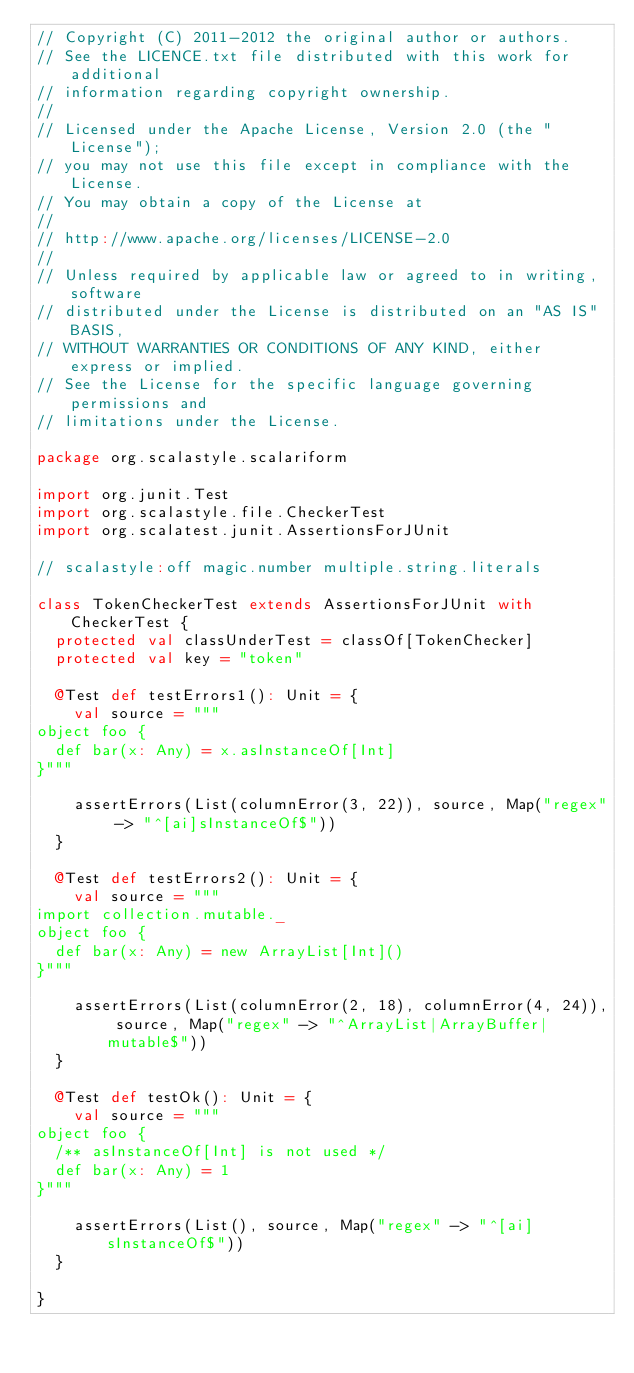<code> <loc_0><loc_0><loc_500><loc_500><_Scala_>// Copyright (C) 2011-2012 the original author or authors.
// See the LICENCE.txt file distributed with this work for additional
// information regarding copyright ownership.
//
// Licensed under the Apache License, Version 2.0 (the "License");
// you may not use this file except in compliance with the License.
// You may obtain a copy of the License at
//
// http://www.apache.org/licenses/LICENSE-2.0
//
// Unless required by applicable law or agreed to in writing, software
// distributed under the License is distributed on an "AS IS" BASIS,
// WITHOUT WARRANTIES OR CONDITIONS OF ANY KIND, either express or implied.
// See the License for the specific language governing permissions and
// limitations under the License.

package org.scalastyle.scalariform

import org.junit.Test
import org.scalastyle.file.CheckerTest
import org.scalatest.junit.AssertionsForJUnit

// scalastyle:off magic.number multiple.string.literals

class TokenCheckerTest extends AssertionsForJUnit with CheckerTest {
  protected val classUnderTest = classOf[TokenChecker]
  protected val key = "token"

  @Test def testErrors1(): Unit = {
    val source = """
object foo {
  def bar(x: Any) = x.asInstanceOf[Int]
}"""

    assertErrors(List(columnError(3, 22)), source, Map("regex" -> "^[ai]sInstanceOf$"))
  }

  @Test def testErrors2(): Unit = {
    val source = """
import collection.mutable._
object foo {
  def bar(x: Any) = new ArrayList[Int]()
}"""

    assertErrors(List(columnError(2, 18), columnError(4, 24)), source, Map("regex" -> "^ArrayList|ArrayBuffer|mutable$"))
  }

  @Test def testOk(): Unit = {
    val source = """
object foo {
  /** asInstanceOf[Int] is not used */
  def bar(x: Any) = 1
}"""

    assertErrors(List(), source, Map("regex" -> "^[ai]sInstanceOf$"))
  }

}
</code> 